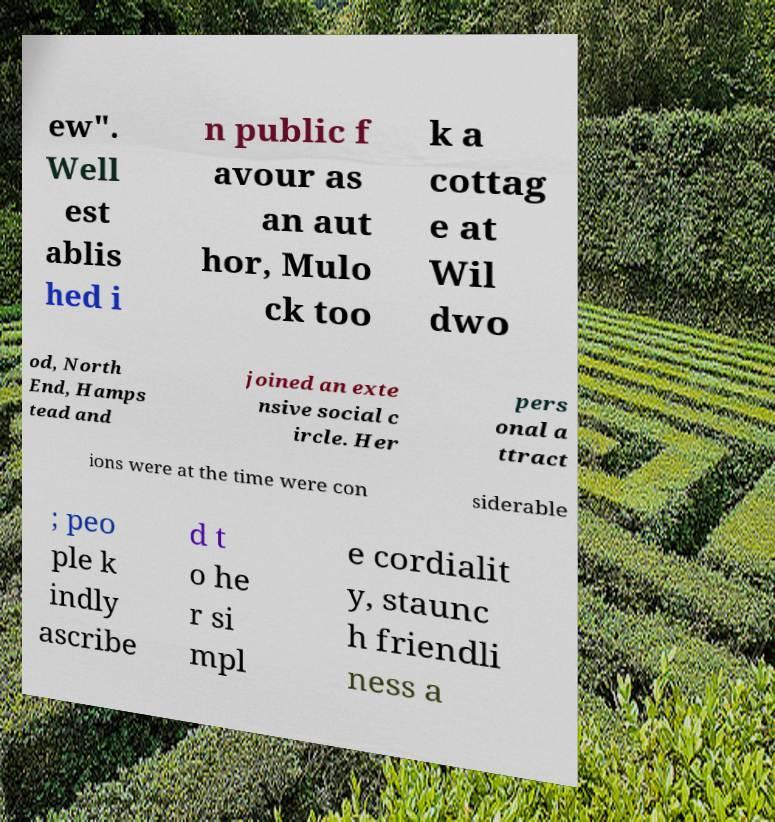Please read and relay the text visible in this image. What does it say? ew". Well est ablis hed i n public f avour as an aut hor, Mulo ck too k a cottag e at Wil dwo od, North End, Hamps tead and joined an exte nsive social c ircle. Her pers onal a ttract ions were at the time were con siderable ; peo ple k indly ascribe d t o he r si mpl e cordialit y, staunc h friendli ness a 